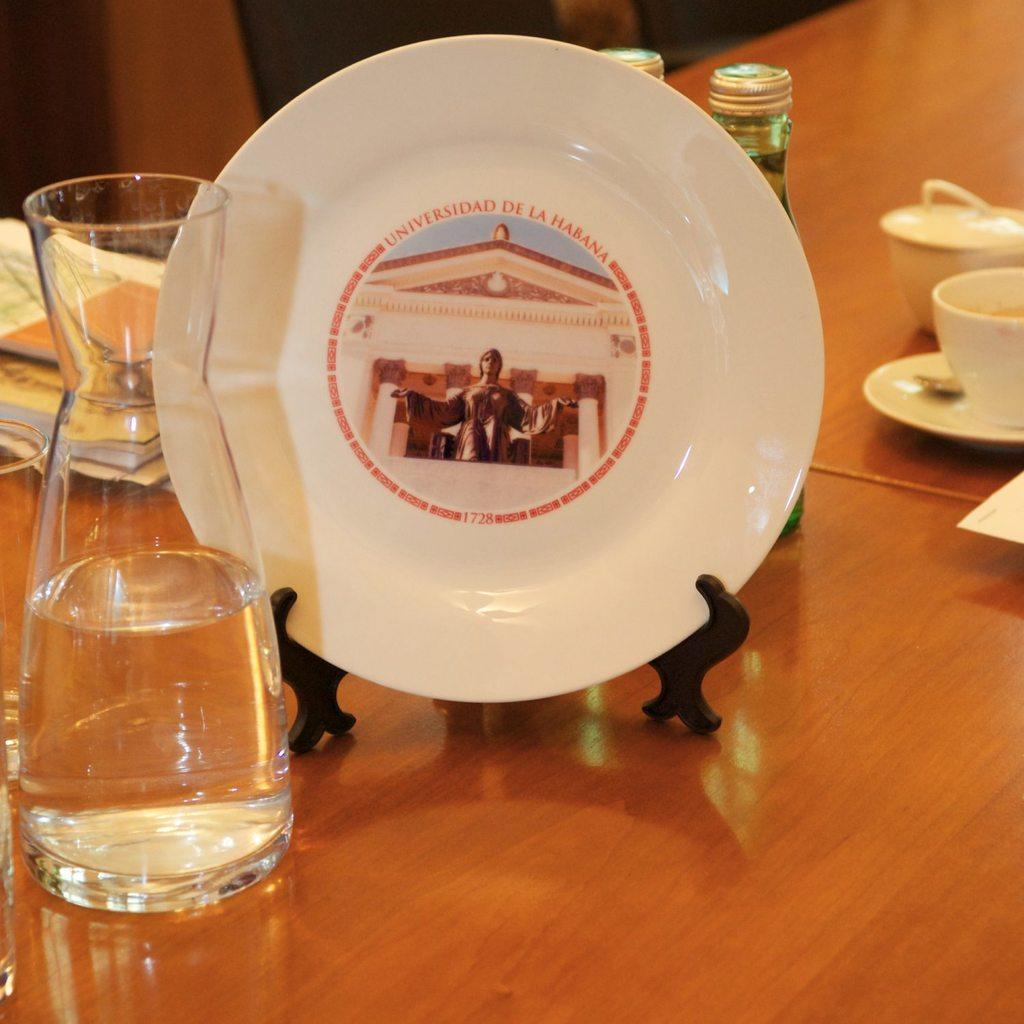What type of furniture is present in the image? There is a table in the image. What is on the table? There is a plate with text, a flask with water, cups, and other objects on the table. Can you describe the plate on the table? The plate has text on it. What is the flask used for? The flask is used for water. What else can be seen in the image besides the table and its contents? There are books in the image. How many turkeys are visible in the image? There are no turkeys present in the image. What type of dust can be seen on the books in the image? There is no dust visible on the books in the image. 